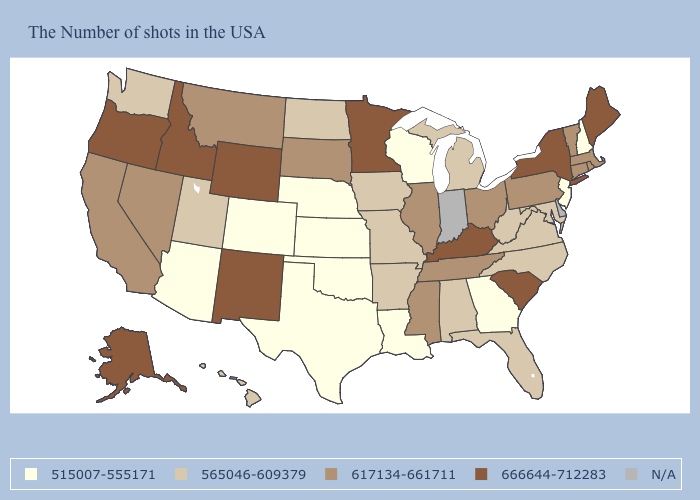Which states hav the highest value in the Northeast?
Keep it brief. Maine, New York. Among the states that border Vermont , which have the lowest value?
Write a very short answer. New Hampshire. Name the states that have a value in the range 565046-609379?
Short answer required. Maryland, Virginia, North Carolina, West Virginia, Florida, Michigan, Alabama, Missouri, Arkansas, Iowa, North Dakota, Utah, Washington, Hawaii. Which states hav the highest value in the MidWest?
Short answer required. Minnesota. Does South Carolina have the highest value in the South?
Quick response, please. Yes. Among the states that border New York , does Vermont have the lowest value?
Short answer required. No. What is the lowest value in states that border Nevada?
Concise answer only. 515007-555171. Name the states that have a value in the range 617134-661711?
Short answer required. Massachusetts, Rhode Island, Vermont, Connecticut, Pennsylvania, Ohio, Tennessee, Illinois, Mississippi, South Dakota, Montana, Nevada, California. Does Wisconsin have the lowest value in the MidWest?
Write a very short answer. Yes. What is the highest value in the South ?
Quick response, please. 666644-712283. Name the states that have a value in the range 515007-555171?
Be succinct. New Hampshire, New Jersey, Georgia, Wisconsin, Louisiana, Kansas, Nebraska, Oklahoma, Texas, Colorado, Arizona. Name the states that have a value in the range 666644-712283?
Concise answer only. Maine, New York, South Carolina, Kentucky, Minnesota, Wyoming, New Mexico, Idaho, Oregon, Alaska. What is the value of Utah?
Give a very brief answer. 565046-609379. 